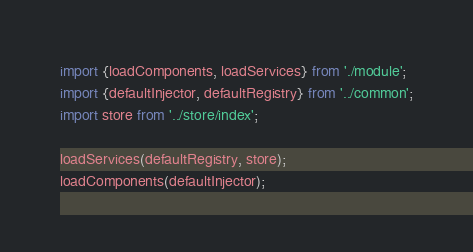<code> <loc_0><loc_0><loc_500><loc_500><_TypeScript_>import {loadComponents, loadServices} from './module';
import {defaultInjector, defaultRegistry} from '../common';
import store from '../store/index';

loadServices(defaultRegistry, store);
loadComponents(defaultInjector);</code> 